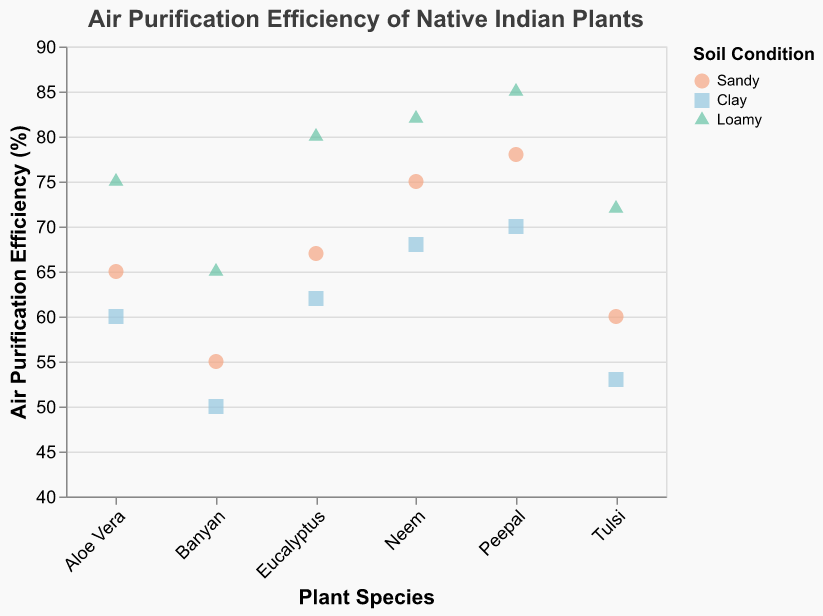How does the air purification efficiency compare between the Neem plant in sandy soil and clay soil? The Neem plant's air purification efficiency in sandy soil is 75%, and in clay soil, it is 68%. By comparing these two values, we see the efficiency is higher in sandy soil.
Answer: Sandy soil is higher Which plant species has the highest air purification efficiency in loamy soil? Observing the data points corresponding to loamy soil conditions, the value for Peepal is the highest at 85%.
Answer: Peepal What is the difference in air purification efficiency between the best and worst-performing plants in sandy soil? The highest air purification efficiency in sandy soil is 78% for Peepal, and the lowest is 55% for Banyan. Therefore, the difference is 78% - 55% = 23%.
Answer: 23% On average, which soil condition results in the highest air purification efficiency across all plant species? Calculate the average efficiency for each soil condition: Sandy ([(75+60+78+55+65+67)/6] = 66.7%), Clay ([(68+53+70+50+60+62)/6] = 60.5%), Loamy ([(82+72+85+65+75+80)/6] = 76.5%). The highest average is for loamy soil.
Answer: Loamy For the Eucalyptus plant, how does the air purification efficiency in loamy soil compare to clay soil? The air purification efficiency for Eucalyptus in loamy soil is 80% and in clay soil is 62%. By comparing these, the loamy soil efficiency is higher.
Answer: Loamy is higher What is the trend line indicating about the relationship between plant species and air purification efficiency? The trend line shows a general increase or decrease across the plant species, implying a correlation between plant species and their air purification efficiency. By examining the trend direction (slope), we observe whether the efficiency typically increases or decreases based on the plant species.
Answer: Increasing/Decreasing (depends on trend observation) Which plant species shows the greatest variability in air purification efficiency across different soil conditions? Variability is gauged by the range within a species. For Neem: (82-68) = 14%, Tulsi: (72-53) = 19%, Peepal: (85-70) = 15%, Banyan: (65-50) = 15%, Aloe Vera: (75-60) = 15%, Eucalyptus: (80-62) = 18%. Tulsi shows the greatest variability.
Answer: Tulsi What is the correlation between soil condition and air purification efficiency in the plant species? By observing the scatter plot points color-coded by soil condition, we notice that loamy soil generally leads to higher air purification efficiency, whereas clay soil leads to lower efficiency. This correlation is visually apparent by identifying the color distribution on the plot.
Answer: Loamy is positively correlated For the Tulsi plant, what is the average air purification efficiency across all soil conditions? Calculate the average for Tulsi's efficiencies: [(60 + 53 + 72)/3] = 61.67%.
Answer: 61.67% Which soil condition is least effective for the Banyan plant in terms of air purification? The air purification efficiencies for Banyan are: Sandy 55%, Clay 50%, Loamy 65%. The least effective soil condition is Clay with 50%.
Answer: Clay 